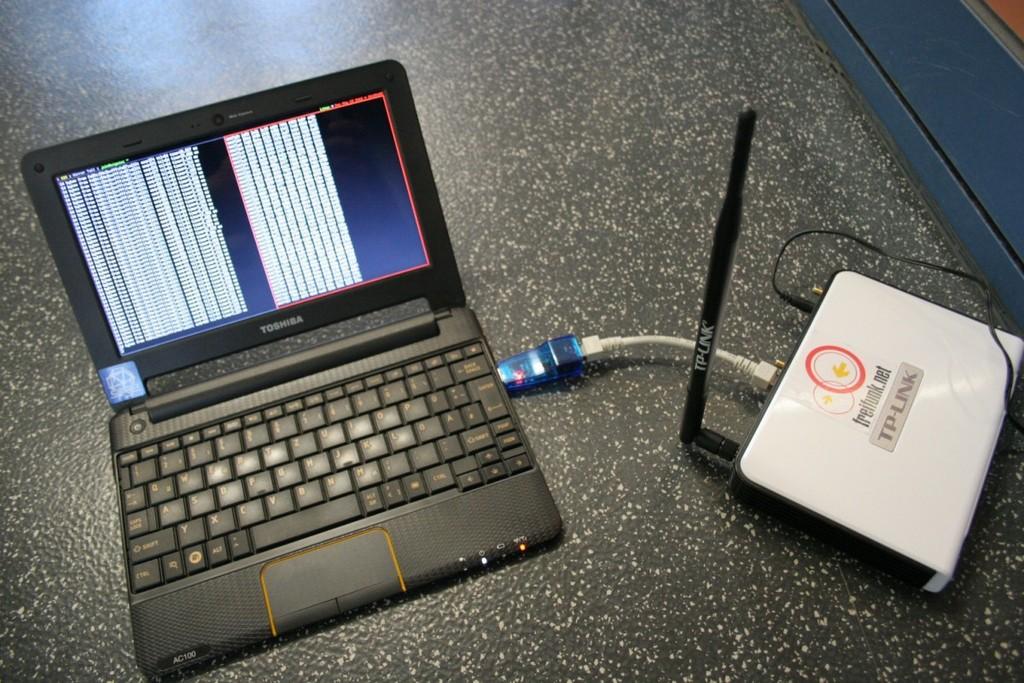What is the brand of the modem?
Offer a terse response. Tp-link. 